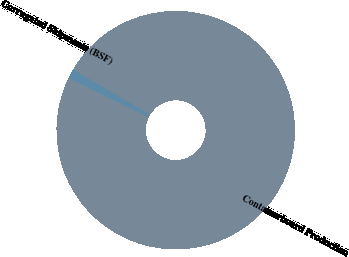<chart> <loc_0><loc_0><loc_500><loc_500><pie_chart><fcel>Containerboard Production<fcel>Corrugated Shipments (BSF)<nl><fcel>98.71%<fcel>1.29%<nl></chart> 